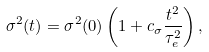Convert formula to latex. <formula><loc_0><loc_0><loc_500><loc_500>\sigma ^ { 2 } ( t ) = \sigma ^ { 2 } ( 0 ) \left ( 1 + c _ { \sigma } \frac { t ^ { 2 } } { \tau _ { e } ^ { 2 } } \right ) ,</formula> 